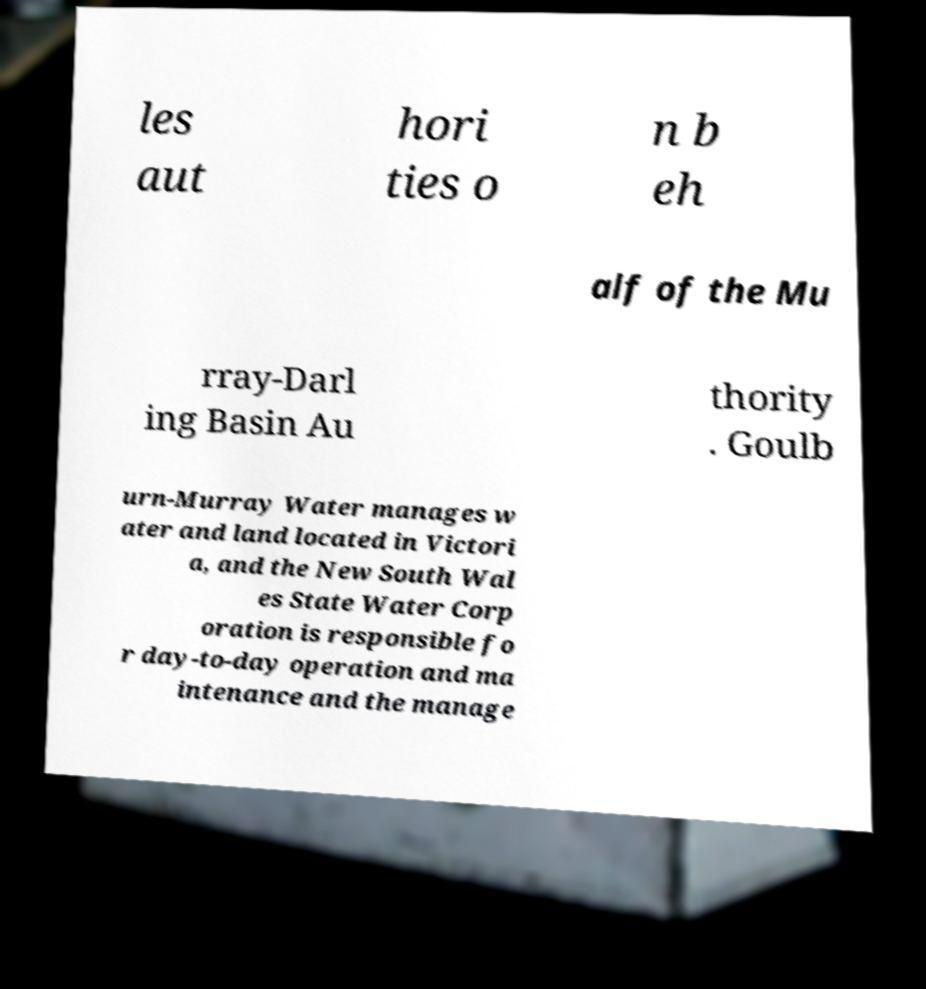Can you read and provide the text displayed in the image?This photo seems to have some interesting text. Can you extract and type it out for me? les aut hori ties o n b eh alf of the Mu rray-Darl ing Basin Au thority . Goulb urn-Murray Water manages w ater and land located in Victori a, and the New South Wal es State Water Corp oration is responsible fo r day-to-day operation and ma intenance and the manage 